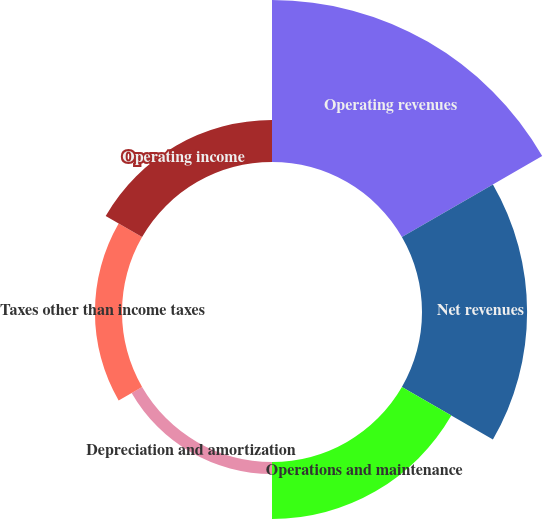<chart> <loc_0><loc_0><loc_500><loc_500><pie_chart><fcel>Operating revenues<fcel>Net revenues<fcel>Operations and maintenance<fcel>Depreciation and amortization<fcel>Taxes other than income taxes<fcel>Operating income<nl><fcel>39.97%<fcel>25.93%<fcel>14.07%<fcel>2.98%<fcel>6.68%<fcel>10.37%<nl></chart> 